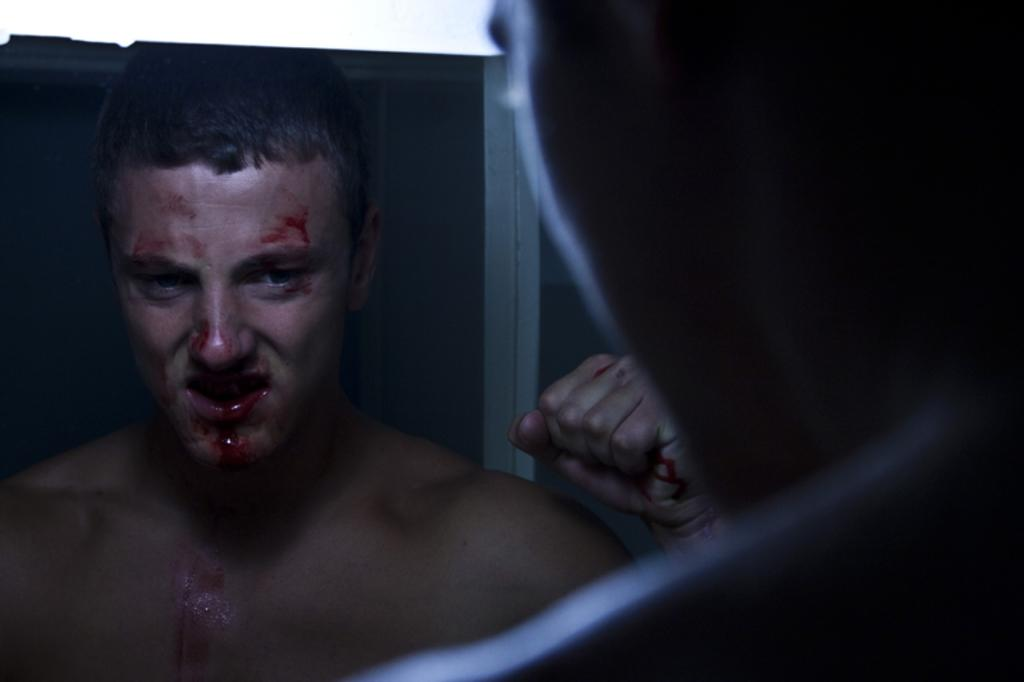What is present in the image? There is a person and their mirror image visible in the image. What is the condition of the mirror image? The mirror image is bleeding. What color is used for the borders of the image? The borders of the image are in white color. What type of plantation can be seen in the image? There is no plantation present in the image. How many hydrants are visible in the image? There are no hydrants visible in the image. 